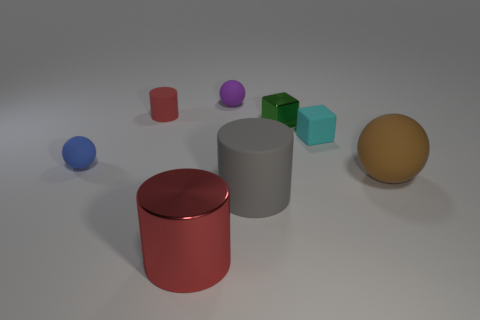How many objects are red cylinders that are in front of the large rubber cylinder or small red matte objects?
Provide a succinct answer. 2. The object that is made of the same material as the large red cylinder is what size?
Offer a terse response. Small. How many large shiny cylinders are the same color as the large matte sphere?
Provide a short and direct response. 0. How many tiny objects are either blue cylinders or cylinders?
Your answer should be compact. 1. What size is the other cylinder that is the same color as the big metallic cylinder?
Provide a succinct answer. Small. Are there any tiny red objects made of the same material as the tiny purple object?
Make the answer very short. Yes. There is a cylinder behind the tiny metal thing; what is its material?
Provide a succinct answer. Rubber. Do the cylinder that is behind the small cyan matte cube and the metal object that is in front of the large brown matte object have the same color?
Your response must be concise. Yes. There is another block that is the same size as the cyan rubber block; what color is it?
Provide a succinct answer. Green. How many other things are the same shape as the purple matte thing?
Make the answer very short. 2. 